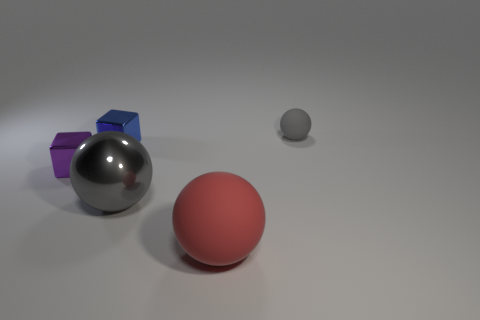Do the sphere right of the red matte ball and the big metallic object have the same color?
Your answer should be compact. Yes. Is there any other thing of the same color as the large metallic thing?
Your answer should be very brief. Yes. The large thing that is the same color as the small matte object is what shape?
Provide a short and direct response. Sphere. What is the size of the object that is the same color as the tiny matte sphere?
Offer a very short reply. Large. How big is the object that is both right of the shiny ball and behind the big matte thing?
Your answer should be compact. Small. What is the size of the blue metal object that is the same shape as the purple shiny object?
Your response must be concise. Small. There is a small sphere; does it have the same color as the metallic object that is right of the small blue metal block?
Offer a terse response. Yes. What color is the object that is behind the large gray sphere and to the right of the small blue metal thing?
Offer a very short reply. Gray. Do the rubber ball that is behind the large gray metal object and the metal thing that is in front of the small purple metallic thing have the same color?
Make the answer very short. Yes. Do the gray sphere that is on the left side of the red thing and the purple metal block that is in front of the small rubber object have the same size?
Offer a very short reply. No. 